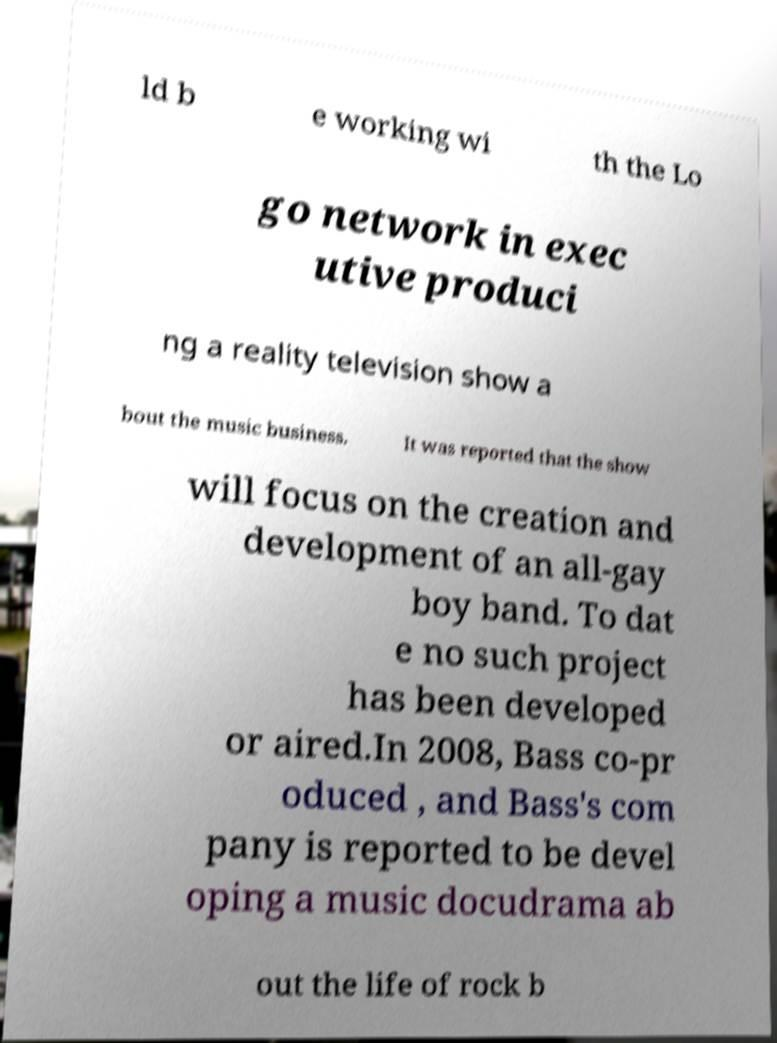Please identify and transcribe the text found in this image. ld b e working wi th the Lo go network in exec utive produci ng a reality television show a bout the music business. It was reported that the show will focus on the creation and development of an all-gay boy band. To dat e no such project has been developed or aired.In 2008, Bass co-pr oduced , and Bass's com pany is reported to be devel oping a music docudrama ab out the life of rock b 